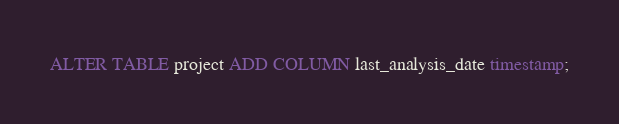<code> <loc_0><loc_0><loc_500><loc_500><_SQL_>ALTER TABLE project ADD COLUMN last_analysis_date timestamp;</code> 